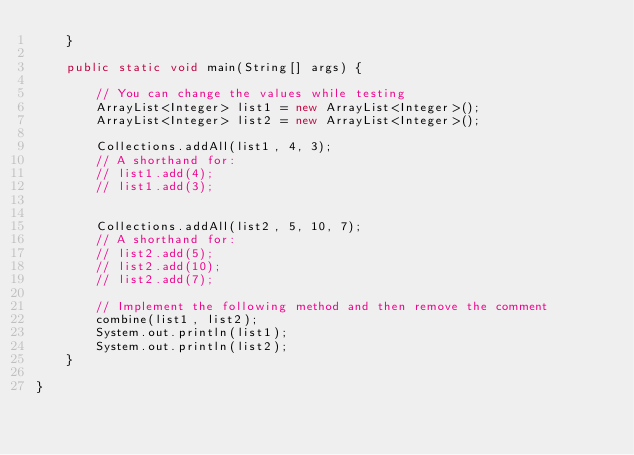<code> <loc_0><loc_0><loc_500><loc_500><_Java_>    }

    public static void main(String[] args) {

        // You can change the values while testing
        ArrayList<Integer> list1 = new ArrayList<Integer>();
        ArrayList<Integer> list2 = new ArrayList<Integer>();

        Collections.addAll(list1, 4, 3);
        // A shorthand for:
        // list1.add(4);
        // list1.add(3);


        Collections.addAll(list2, 5, 10, 7);
        // A shorthand for:
        // list2.add(5);
        // list2.add(10);
        // list2.add(7);

        // Implement the following method and then remove the comment
        combine(list1, list2);
        System.out.println(list1);
        System.out.println(list2);
    }

}
</code> 